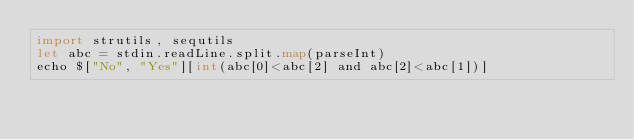Convert code to text. <code><loc_0><loc_0><loc_500><loc_500><_Nim_>import strutils, sequtils
let abc = stdin.readLine.split.map(parseInt)
echo $["No", "Yes"][int(abc[0]<abc[2] and abc[2]<abc[1])]</code> 